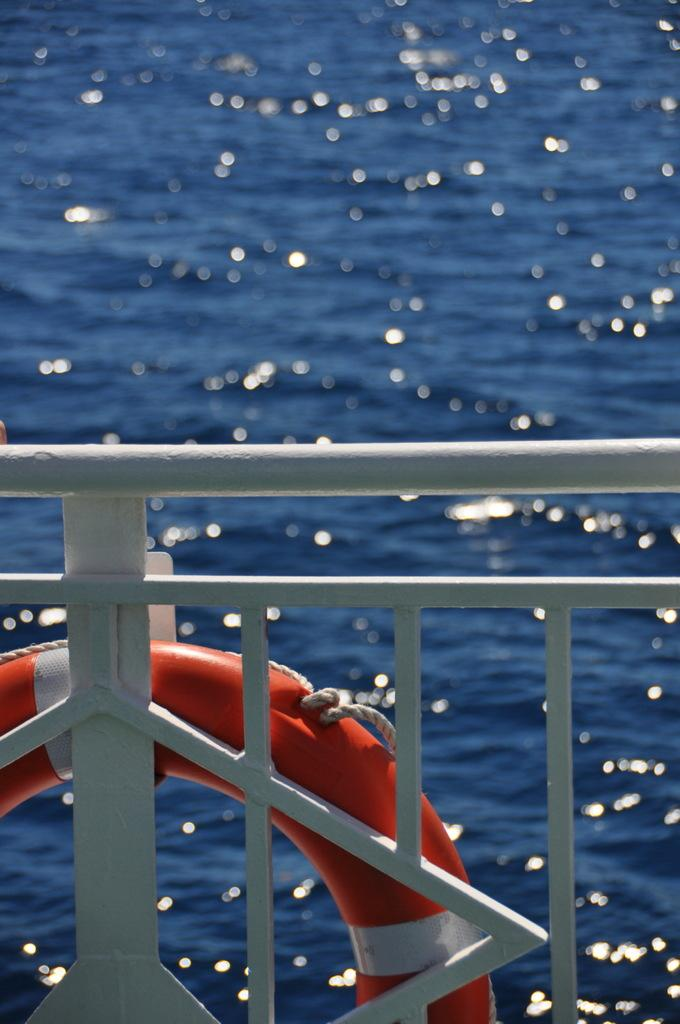What can be seen in the image that might be used for support or safety? There is a railing in the image that could be used for support or safety. What is hanging on the railing in the image? A ring is hanging on the railing in the image. What natural feature can be seen in the background of the image? There is a river visible in the background of the image. Where is the nest located in the image? There is no nest present in the image. Can you find the receipt for the ring hanging on the railing in the image? There is no receipt visible in the image. 